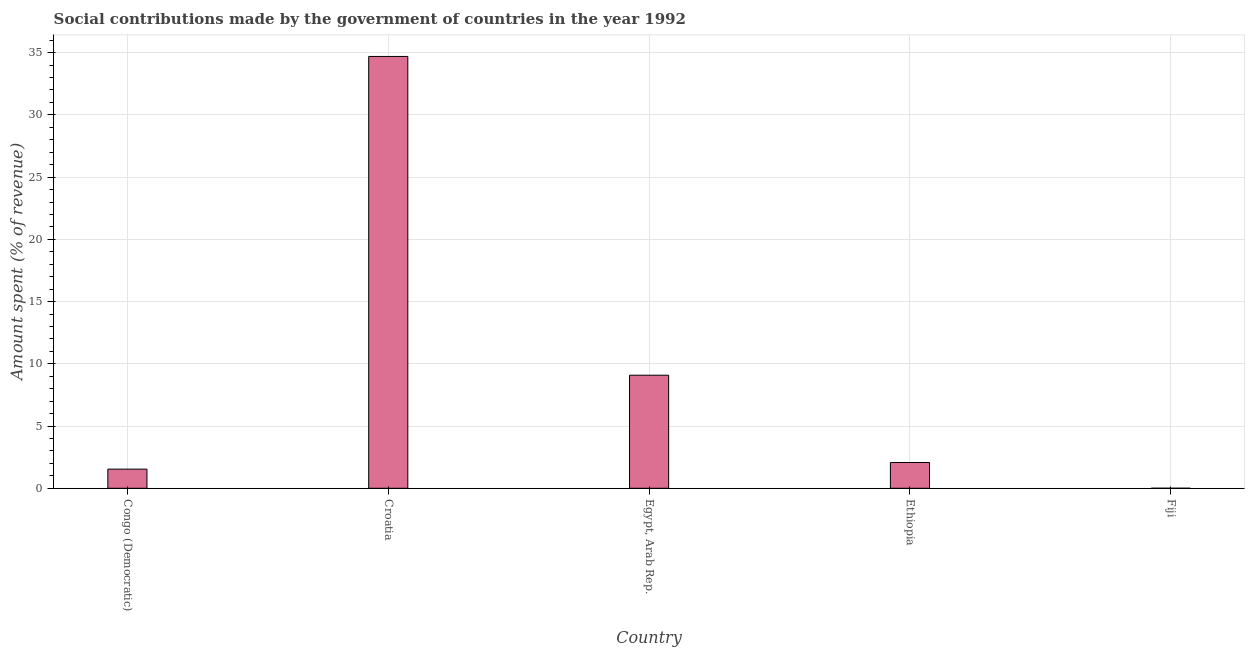Does the graph contain grids?
Your response must be concise. Yes. What is the title of the graph?
Your answer should be compact. Social contributions made by the government of countries in the year 1992. What is the label or title of the X-axis?
Keep it short and to the point. Country. What is the label or title of the Y-axis?
Your response must be concise. Amount spent (% of revenue). What is the amount spent in making social contributions in Croatia?
Your answer should be compact. 34.69. Across all countries, what is the maximum amount spent in making social contributions?
Your response must be concise. 34.69. Across all countries, what is the minimum amount spent in making social contributions?
Offer a very short reply. 0. In which country was the amount spent in making social contributions maximum?
Ensure brevity in your answer.  Croatia. In which country was the amount spent in making social contributions minimum?
Give a very brief answer. Fiji. What is the sum of the amount spent in making social contributions?
Your answer should be very brief. 47.39. What is the difference between the amount spent in making social contributions in Croatia and Fiji?
Keep it short and to the point. 34.69. What is the average amount spent in making social contributions per country?
Keep it short and to the point. 9.48. What is the median amount spent in making social contributions?
Your answer should be very brief. 2.07. In how many countries, is the amount spent in making social contributions greater than 1 %?
Offer a terse response. 4. What is the ratio of the amount spent in making social contributions in Croatia to that in Ethiopia?
Your answer should be very brief. 16.74. Is the amount spent in making social contributions in Egypt, Arab Rep. less than that in Ethiopia?
Provide a short and direct response. No. Is the difference between the amount spent in making social contributions in Congo (Democratic) and Fiji greater than the difference between any two countries?
Provide a succinct answer. No. What is the difference between the highest and the second highest amount spent in making social contributions?
Keep it short and to the point. 25.61. What is the difference between the highest and the lowest amount spent in making social contributions?
Your response must be concise. 34.69. How many bars are there?
Provide a short and direct response. 5. Are all the bars in the graph horizontal?
Make the answer very short. No. What is the difference between two consecutive major ticks on the Y-axis?
Provide a short and direct response. 5. Are the values on the major ticks of Y-axis written in scientific E-notation?
Offer a terse response. No. What is the Amount spent (% of revenue) in Congo (Democratic)?
Your answer should be compact. 1.54. What is the Amount spent (% of revenue) of Croatia?
Make the answer very short. 34.69. What is the Amount spent (% of revenue) in Egypt, Arab Rep.?
Provide a short and direct response. 9.08. What is the Amount spent (% of revenue) in Ethiopia?
Provide a succinct answer. 2.07. What is the Amount spent (% of revenue) in Fiji?
Give a very brief answer. 0. What is the difference between the Amount spent (% of revenue) in Congo (Democratic) and Croatia?
Ensure brevity in your answer.  -33.16. What is the difference between the Amount spent (% of revenue) in Congo (Democratic) and Egypt, Arab Rep.?
Provide a short and direct response. -7.55. What is the difference between the Amount spent (% of revenue) in Congo (Democratic) and Ethiopia?
Provide a succinct answer. -0.53. What is the difference between the Amount spent (% of revenue) in Congo (Democratic) and Fiji?
Your response must be concise. 1.54. What is the difference between the Amount spent (% of revenue) in Croatia and Egypt, Arab Rep.?
Offer a terse response. 25.61. What is the difference between the Amount spent (% of revenue) in Croatia and Ethiopia?
Ensure brevity in your answer.  32.62. What is the difference between the Amount spent (% of revenue) in Croatia and Fiji?
Provide a succinct answer. 34.69. What is the difference between the Amount spent (% of revenue) in Egypt, Arab Rep. and Ethiopia?
Your response must be concise. 7.01. What is the difference between the Amount spent (% of revenue) in Egypt, Arab Rep. and Fiji?
Ensure brevity in your answer.  9.08. What is the difference between the Amount spent (% of revenue) in Ethiopia and Fiji?
Offer a very short reply. 2.07. What is the ratio of the Amount spent (% of revenue) in Congo (Democratic) to that in Croatia?
Your response must be concise. 0.04. What is the ratio of the Amount spent (% of revenue) in Congo (Democratic) to that in Egypt, Arab Rep.?
Your answer should be compact. 0.17. What is the ratio of the Amount spent (% of revenue) in Congo (Democratic) to that in Ethiopia?
Your answer should be compact. 0.74. What is the ratio of the Amount spent (% of revenue) in Congo (Democratic) to that in Fiji?
Make the answer very short. 900.23. What is the ratio of the Amount spent (% of revenue) in Croatia to that in Egypt, Arab Rep.?
Your response must be concise. 3.82. What is the ratio of the Amount spent (% of revenue) in Croatia to that in Ethiopia?
Your response must be concise. 16.74. What is the ratio of the Amount spent (% of revenue) in Croatia to that in Fiji?
Your response must be concise. 2.03e+04. What is the ratio of the Amount spent (% of revenue) in Egypt, Arab Rep. to that in Ethiopia?
Your answer should be very brief. 4.38. What is the ratio of the Amount spent (% of revenue) in Egypt, Arab Rep. to that in Fiji?
Provide a short and direct response. 5315.62. What is the ratio of the Amount spent (% of revenue) in Ethiopia to that in Fiji?
Ensure brevity in your answer.  1212.77. 